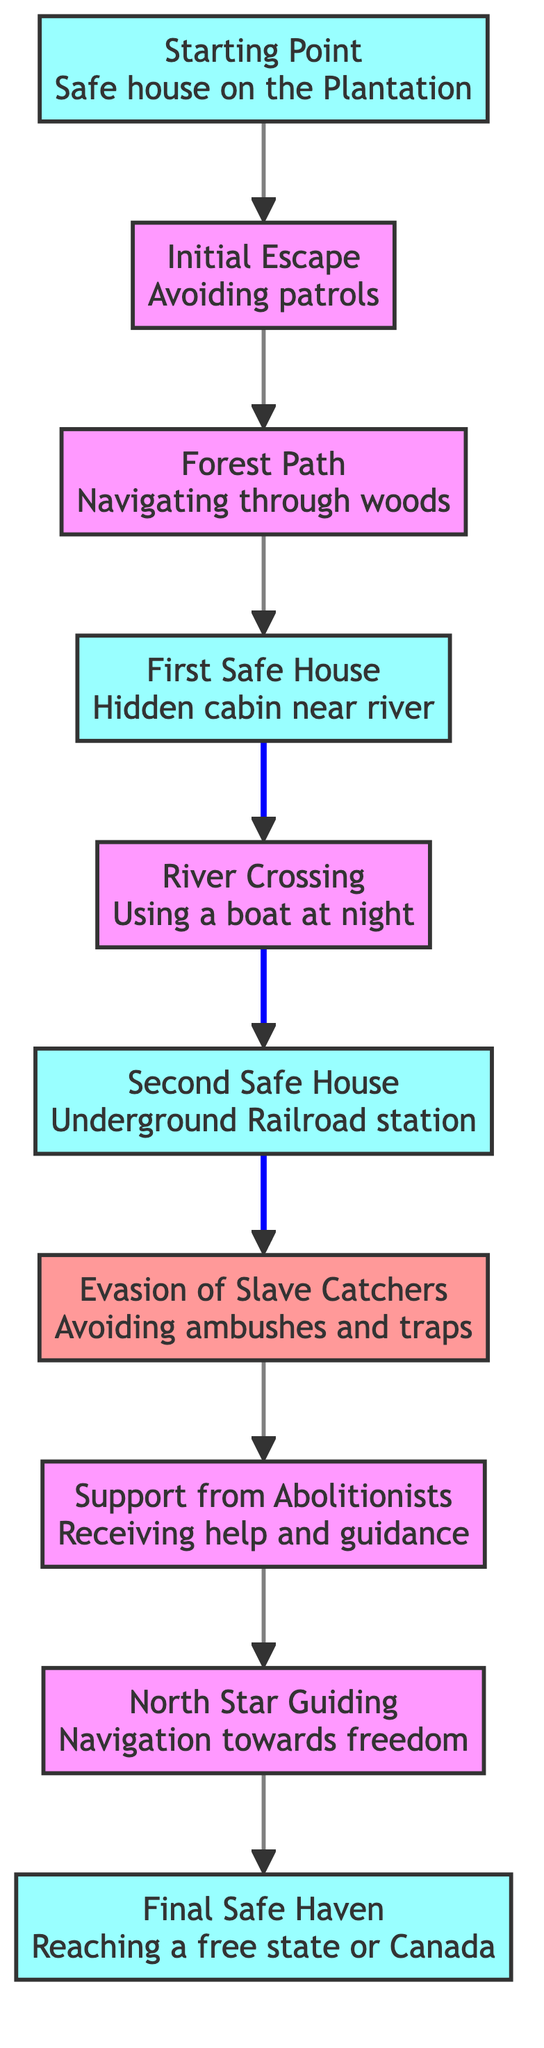What is the starting point of the escape plan? The starting point is labeled as "Safe house on the Plantation" in the diagram. This is the first element listed and is the initial node from which the escape begins.
Answer: Safe house on the Plantation How many safe houses are there in the escape plan? The nodes representing safe houses are the Starting Point, First Safe House, Second Safe House, and Final Safe Haven. There are four designated safe houses in total.
Answer: 4 What is the first step after the Initial Escape? Following the Initial Escape, the next step indicated in the flowchart is the Forest Path. This relationship is clearly shown as a direct link in the diagram.
Answer: Forest Path What leads to the Evasion of Slave Catchers? The prerequisite for Evasion of Slave Catchers is arriving at the Second Safe House. This relationship requires completing the River Crossing task before progressing to avoiding ambushes and traps.
Answer: Second Safe House What aids the escapees after evading slave catchers? After successfully evading slave catchers, the next step involves receiving Support from Abolitionists. This stage provides crucial assistance and guidance for continuing their journey.
Answer: Support from Abolitionists How does one navigate towards freedom? The escapees use the North Star for navigation after receiving support from abolitionists. This element emphasizes the importance of navigation in their journey towards freedom.
Answer: North Star Guiding What is the final destination in the escape route? The last node in the flowchart is labeled "Final Safe Haven," which indicates the ultimate destination for escapees, where they reach safety in a free state or Canada.
Answer: Final Safe Haven What is the relationship between the First Safe House and the River Crossing? The First Safe House directly leads to the River Crossing, as indicated by the arrow connecting these two nodes in the diagram. This shows a sequential process in the escape.
Answer: River Crossing What type of danger is represented in the diagram? The danger represented in the diagram refers to the Evasion of Slave Catchers, which illustrates the risk of ambushes and traps that escapees must navigate around.
Answer: Evasion of Slave Catchers 